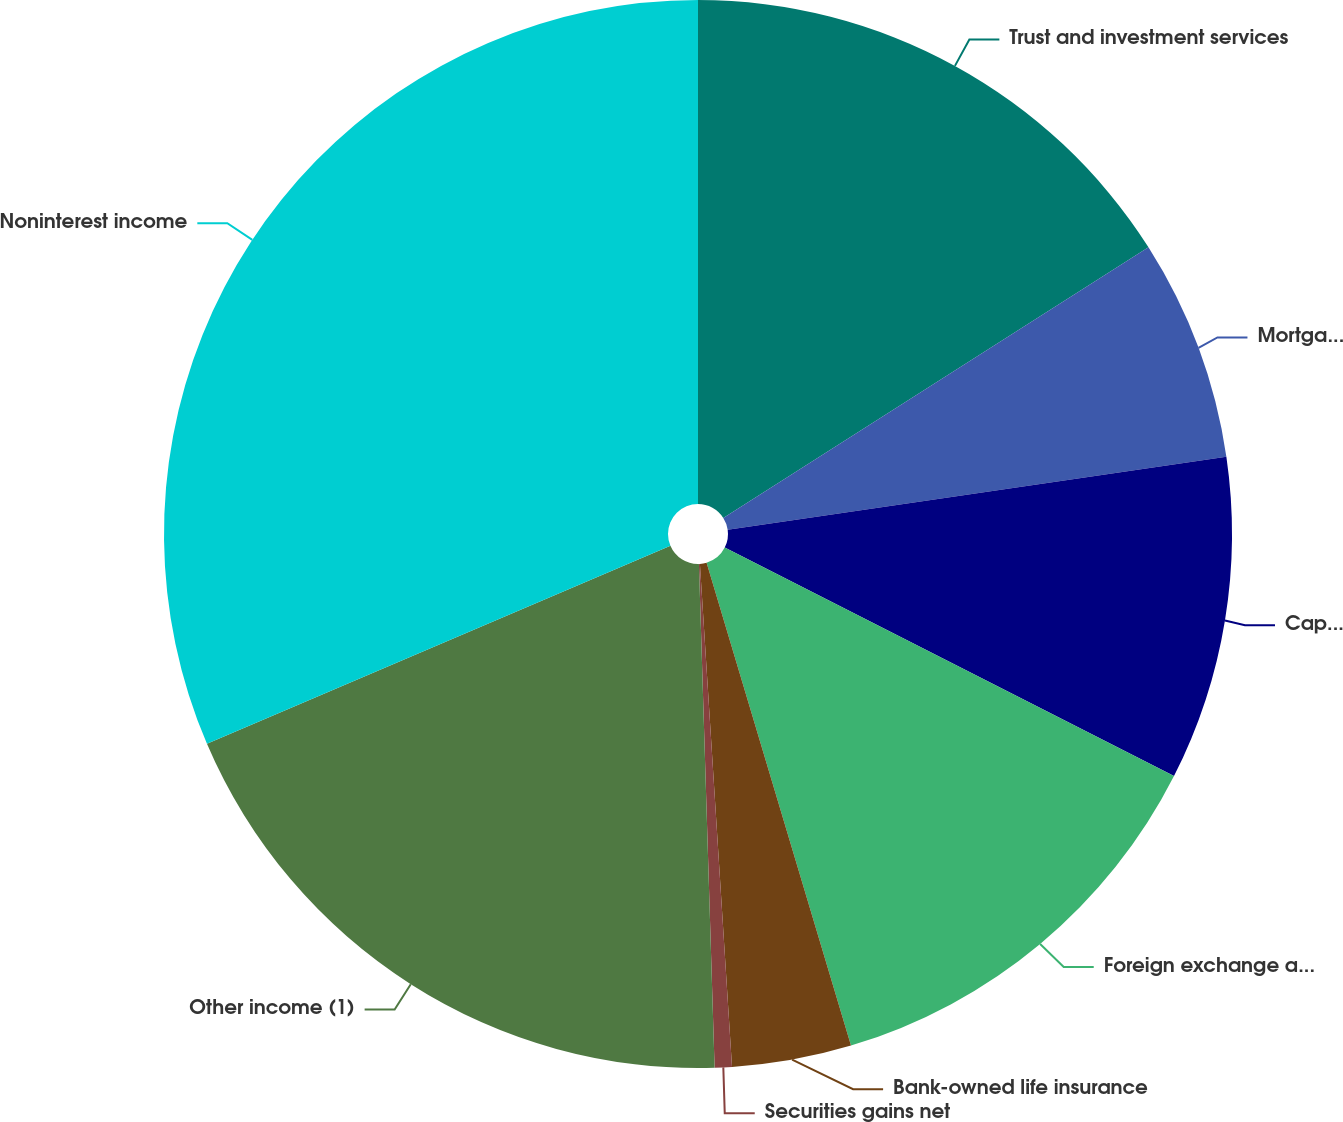Convert chart to OTSL. <chart><loc_0><loc_0><loc_500><loc_500><pie_chart><fcel>Trust and investment services<fcel>Mortgage banking fees<fcel>Capital markets fees<fcel>Foreign exchange and letter of<fcel>Bank-owned life insurance<fcel>Securities gains net<fcel>Other income (1)<fcel>Noninterest income<nl><fcel>15.98%<fcel>6.71%<fcel>9.8%<fcel>12.89%<fcel>3.61%<fcel>0.52%<fcel>19.07%<fcel>31.43%<nl></chart> 